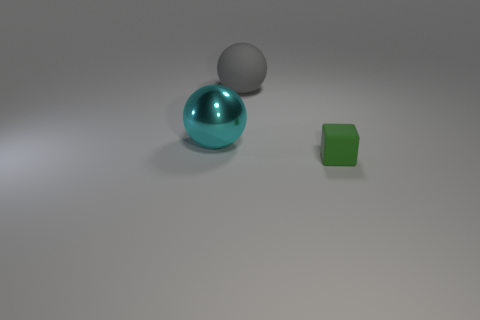How many objects are in front of the large gray rubber sphere and left of the tiny green thing?
Provide a short and direct response. 1. What is the material of the cyan ball that is left of the matte sphere?
Provide a short and direct response. Metal. What is the size of the sphere that is the same material as the tiny green thing?
Your answer should be compact. Large. Is the size of the rubber object that is behind the green rubber thing the same as the rubber object that is in front of the cyan metallic object?
Your answer should be compact. No. There is another gray object that is the same size as the shiny object; what is its material?
Your answer should be compact. Rubber. What is the thing that is on the left side of the green object and to the right of the large shiny ball made of?
Make the answer very short. Rubber. Are any spheres visible?
Make the answer very short. Yes. There is a small matte object; does it have the same color as the large ball that is right of the cyan object?
Your response must be concise. No. Is there any other thing that has the same shape as the big cyan metal object?
Offer a very short reply. Yes. What is the shape of the big object on the right side of the thing that is left of the rubber thing on the left side of the tiny matte cube?
Provide a short and direct response. Sphere. 